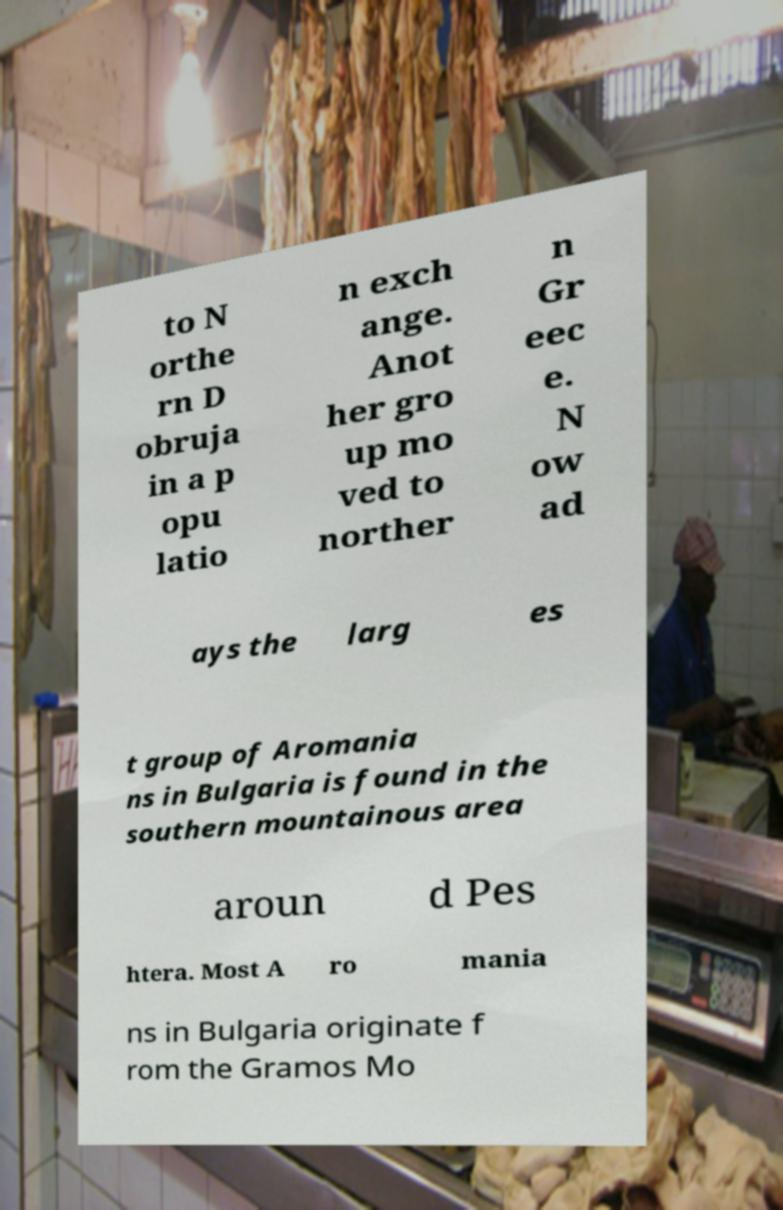What messages or text are displayed in this image? I need them in a readable, typed format. to N orthe rn D obruja in a p opu latio n exch ange. Anot her gro up mo ved to norther n Gr eec e. N ow ad ays the larg es t group of Aromania ns in Bulgaria is found in the southern mountainous area aroun d Pes htera. Most A ro mania ns in Bulgaria originate f rom the Gramos Mo 